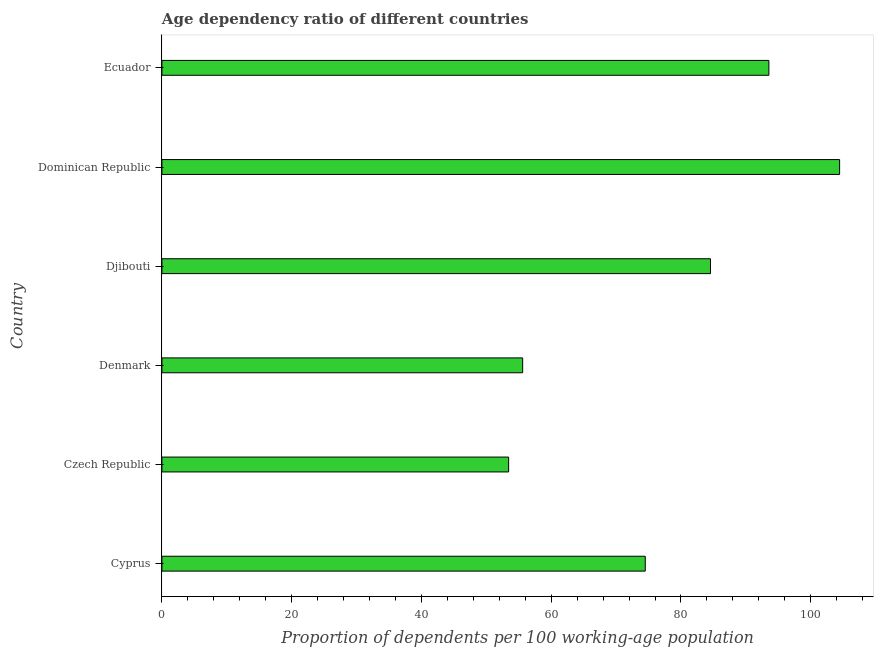Does the graph contain any zero values?
Keep it short and to the point. No. What is the title of the graph?
Offer a very short reply. Age dependency ratio of different countries. What is the label or title of the X-axis?
Offer a terse response. Proportion of dependents per 100 working-age population. What is the label or title of the Y-axis?
Keep it short and to the point. Country. What is the age dependency ratio in Djibouti?
Your response must be concise. 84.55. Across all countries, what is the maximum age dependency ratio?
Offer a terse response. 104.45. Across all countries, what is the minimum age dependency ratio?
Keep it short and to the point. 53.44. In which country was the age dependency ratio maximum?
Your response must be concise. Dominican Republic. In which country was the age dependency ratio minimum?
Provide a short and direct response. Czech Republic. What is the sum of the age dependency ratio?
Your answer should be compact. 466.08. What is the difference between the age dependency ratio in Czech Republic and Djibouti?
Provide a short and direct response. -31.11. What is the average age dependency ratio per country?
Your response must be concise. 77.68. What is the median age dependency ratio?
Keep it short and to the point. 79.52. What is the ratio of the age dependency ratio in Denmark to that in Dominican Republic?
Give a very brief answer. 0.53. Is the difference between the age dependency ratio in Cyprus and Czech Republic greater than the difference between any two countries?
Ensure brevity in your answer.  No. What is the difference between the highest and the second highest age dependency ratio?
Offer a very short reply. 10.9. Is the sum of the age dependency ratio in Djibouti and Dominican Republic greater than the maximum age dependency ratio across all countries?
Give a very brief answer. Yes. What is the difference between the highest and the lowest age dependency ratio?
Your response must be concise. 51.01. In how many countries, is the age dependency ratio greater than the average age dependency ratio taken over all countries?
Give a very brief answer. 3. How many bars are there?
Your response must be concise. 6. What is the difference between two consecutive major ticks on the X-axis?
Offer a very short reply. 20. Are the values on the major ticks of X-axis written in scientific E-notation?
Your answer should be very brief. No. What is the Proportion of dependents per 100 working-age population of Cyprus?
Provide a succinct answer. 74.5. What is the Proportion of dependents per 100 working-age population of Czech Republic?
Your response must be concise. 53.44. What is the Proportion of dependents per 100 working-age population in Denmark?
Your response must be concise. 55.6. What is the Proportion of dependents per 100 working-age population in Djibouti?
Offer a very short reply. 84.55. What is the Proportion of dependents per 100 working-age population in Dominican Republic?
Keep it short and to the point. 104.45. What is the Proportion of dependents per 100 working-age population of Ecuador?
Your answer should be very brief. 93.55. What is the difference between the Proportion of dependents per 100 working-age population in Cyprus and Czech Republic?
Your answer should be very brief. 21.06. What is the difference between the Proportion of dependents per 100 working-age population in Cyprus and Denmark?
Offer a very short reply. 18.9. What is the difference between the Proportion of dependents per 100 working-age population in Cyprus and Djibouti?
Keep it short and to the point. -10.05. What is the difference between the Proportion of dependents per 100 working-age population in Cyprus and Dominican Republic?
Provide a short and direct response. -29.95. What is the difference between the Proportion of dependents per 100 working-age population in Cyprus and Ecuador?
Provide a short and direct response. -19.05. What is the difference between the Proportion of dependents per 100 working-age population in Czech Republic and Denmark?
Provide a short and direct response. -2.16. What is the difference between the Proportion of dependents per 100 working-age population in Czech Republic and Djibouti?
Give a very brief answer. -31.11. What is the difference between the Proportion of dependents per 100 working-age population in Czech Republic and Dominican Republic?
Keep it short and to the point. -51.01. What is the difference between the Proportion of dependents per 100 working-age population in Czech Republic and Ecuador?
Provide a succinct answer. -40.11. What is the difference between the Proportion of dependents per 100 working-age population in Denmark and Djibouti?
Your answer should be compact. -28.95. What is the difference between the Proportion of dependents per 100 working-age population in Denmark and Dominican Republic?
Offer a terse response. -48.85. What is the difference between the Proportion of dependents per 100 working-age population in Denmark and Ecuador?
Your answer should be very brief. -37.95. What is the difference between the Proportion of dependents per 100 working-age population in Djibouti and Dominican Republic?
Ensure brevity in your answer.  -19.9. What is the difference between the Proportion of dependents per 100 working-age population in Djibouti and Ecuador?
Make the answer very short. -9. What is the difference between the Proportion of dependents per 100 working-age population in Dominican Republic and Ecuador?
Make the answer very short. 10.9. What is the ratio of the Proportion of dependents per 100 working-age population in Cyprus to that in Czech Republic?
Give a very brief answer. 1.39. What is the ratio of the Proportion of dependents per 100 working-age population in Cyprus to that in Denmark?
Give a very brief answer. 1.34. What is the ratio of the Proportion of dependents per 100 working-age population in Cyprus to that in Djibouti?
Your answer should be very brief. 0.88. What is the ratio of the Proportion of dependents per 100 working-age population in Cyprus to that in Dominican Republic?
Ensure brevity in your answer.  0.71. What is the ratio of the Proportion of dependents per 100 working-age population in Cyprus to that in Ecuador?
Offer a very short reply. 0.8. What is the ratio of the Proportion of dependents per 100 working-age population in Czech Republic to that in Djibouti?
Give a very brief answer. 0.63. What is the ratio of the Proportion of dependents per 100 working-age population in Czech Republic to that in Dominican Republic?
Offer a very short reply. 0.51. What is the ratio of the Proportion of dependents per 100 working-age population in Czech Republic to that in Ecuador?
Your response must be concise. 0.57. What is the ratio of the Proportion of dependents per 100 working-age population in Denmark to that in Djibouti?
Ensure brevity in your answer.  0.66. What is the ratio of the Proportion of dependents per 100 working-age population in Denmark to that in Dominican Republic?
Give a very brief answer. 0.53. What is the ratio of the Proportion of dependents per 100 working-age population in Denmark to that in Ecuador?
Keep it short and to the point. 0.59. What is the ratio of the Proportion of dependents per 100 working-age population in Djibouti to that in Dominican Republic?
Keep it short and to the point. 0.81. What is the ratio of the Proportion of dependents per 100 working-age population in Djibouti to that in Ecuador?
Your answer should be very brief. 0.9. What is the ratio of the Proportion of dependents per 100 working-age population in Dominican Republic to that in Ecuador?
Your response must be concise. 1.12. 